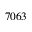Convert formula to latex. <formula><loc_0><loc_0><loc_500><loc_500>7 0 6 3</formula> 